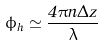<formula> <loc_0><loc_0><loc_500><loc_500>\phi _ { h } \simeq \frac { 4 \pi n \Delta z } { \lambda }</formula> 